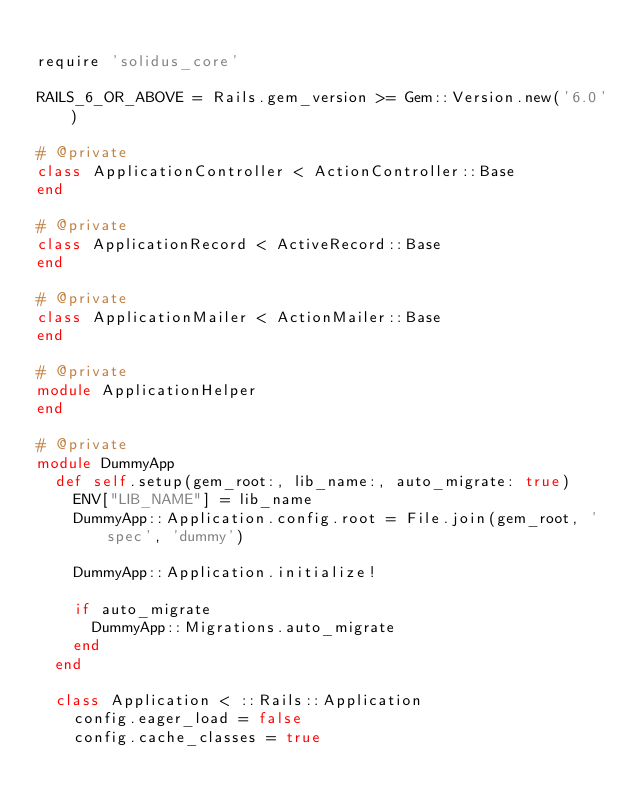Convert code to text. <code><loc_0><loc_0><loc_500><loc_500><_Ruby_>
require 'solidus_core'

RAILS_6_OR_ABOVE = Rails.gem_version >= Gem::Version.new('6.0')

# @private
class ApplicationController < ActionController::Base
end

# @private
class ApplicationRecord < ActiveRecord::Base
end

# @private
class ApplicationMailer < ActionMailer::Base
end

# @private
module ApplicationHelper
end

# @private
module DummyApp
  def self.setup(gem_root:, lib_name:, auto_migrate: true)
    ENV["LIB_NAME"] = lib_name
    DummyApp::Application.config.root = File.join(gem_root, 'spec', 'dummy')

    DummyApp::Application.initialize!

    if auto_migrate
      DummyApp::Migrations.auto_migrate
    end
  end

  class Application < ::Rails::Application
    config.eager_load = false
    config.cache_classes = true</code> 